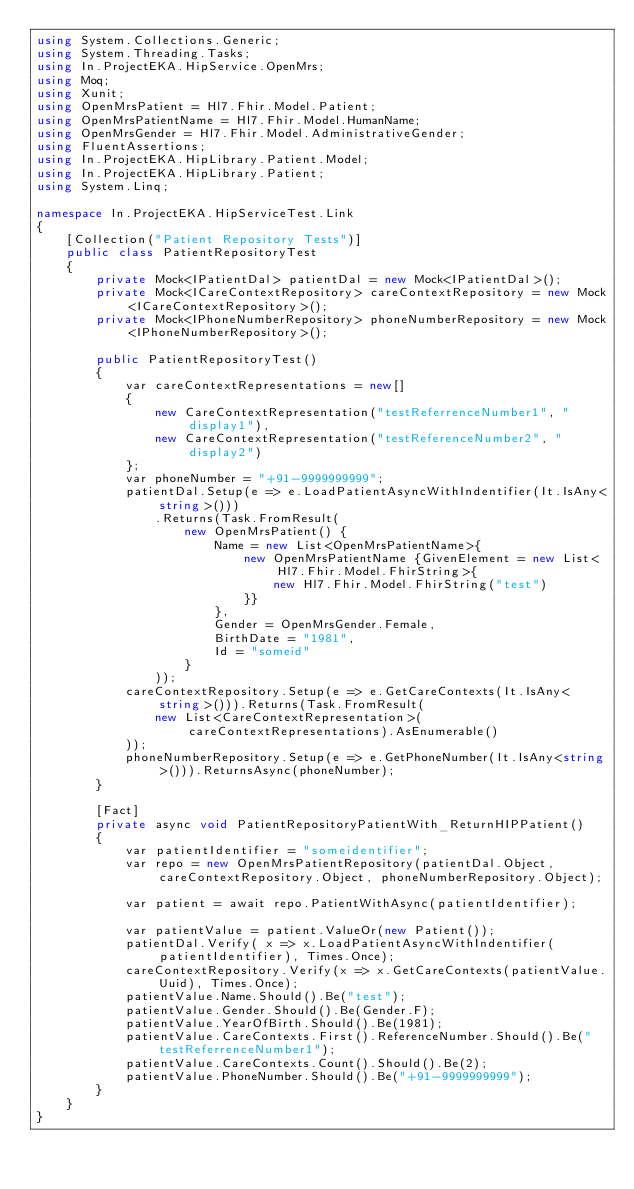Convert code to text. <code><loc_0><loc_0><loc_500><loc_500><_C#_>using System.Collections.Generic;
using System.Threading.Tasks;
using In.ProjectEKA.HipService.OpenMrs;
using Moq;
using Xunit;
using OpenMrsPatient = Hl7.Fhir.Model.Patient;
using OpenMrsPatientName = Hl7.Fhir.Model.HumanName;
using OpenMrsGender = Hl7.Fhir.Model.AdministrativeGender;
using FluentAssertions;
using In.ProjectEKA.HipLibrary.Patient.Model;
using In.ProjectEKA.HipLibrary.Patient;
using System.Linq;

namespace In.ProjectEKA.HipServiceTest.Link
{
    [Collection("Patient Repository Tests")]
    public class PatientRepositoryTest
    {
        private Mock<IPatientDal> patientDal = new Mock<IPatientDal>();
        private Mock<ICareContextRepository> careContextRepository = new Mock<ICareContextRepository>();
        private Mock<IPhoneNumberRepository> phoneNumberRepository = new Mock<IPhoneNumberRepository>();

        public PatientRepositoryTest()
        {
            var careContextRepresentations = new[]
            {
                new CareContextRepresentation("testReferrenceNumber1", "display1"),
                new CareContextRepresentation("testReferenceNumber2", "display2")
            };
            var phoneNumber = "+91-9999999999";
            patientDal.Setup(e => e.LoadPatientAsyncWithIndentifier(It.IsAny<string>()))
                .Returns(Task.FromResult(
                    new OpenMrsPatient() {
                        Name = new List<OpenMrsPatientName>{
                            new OpenMrsPatientName {GivenElement = new List<Hl7.Fhir.Model.FhirString>{
                                new Hl7.Fhir.Model.FhirString("test")
                            }}
                        },
                        Gender = OpenMrsGender.Female,
                        BirthDate = "1981",
                        Id = "someid"
                    }
                ));
            careContextRepository.Setup(e => e.GetCareContexts(It.IsAny<string>())).Returns(Task.FromResult(
                new List<CareContextRepresentation>(careContextRepresentations).AsEnumerable()
            ));
            phoneNumberRepository.Setup(e => e.GetPhoneNumber(It.IsAny<string>())).ReturnsAsync(phoneNumber);
        }

        [Fact]
        private async void PatientRepositoryPatientWith_ReturnHIPPatient()
        {
            var patientIdentifier = "someidentifier";
            var repo = new OpenMrsPatientRepository(patientDal.Object, careContextRepository.Object, phoneNumberRepository.Object);

            var patient = await repo.PatientWithAsync(patientIdentifier);

            var patientValue = patient.ValueOr(new Patient());
            patientDal.Verify( x => x.LoadPatientAsyncWithIndentifier(patientIdentifier), Times.Once);
            careContextRepository.Verify(x => x.GetCareContexts(patientValue.Uuid), Times.Once);
            patientValue.Name.Should().Be("test");
            patientValue.Gender.Should().Be(Gender.F);
            patientValue.YearOfBirth.Should().Be(1981);
            patientValue.CareContexts.First().ReferenceNumber.Should().Be("testReferrenceNumber1");
            patientValue.CareContexts.Count().Should().Be(2);
            patientValue.PhoneNumber.Should().Be("+91-9999999999");
        }
    }
}</code> 